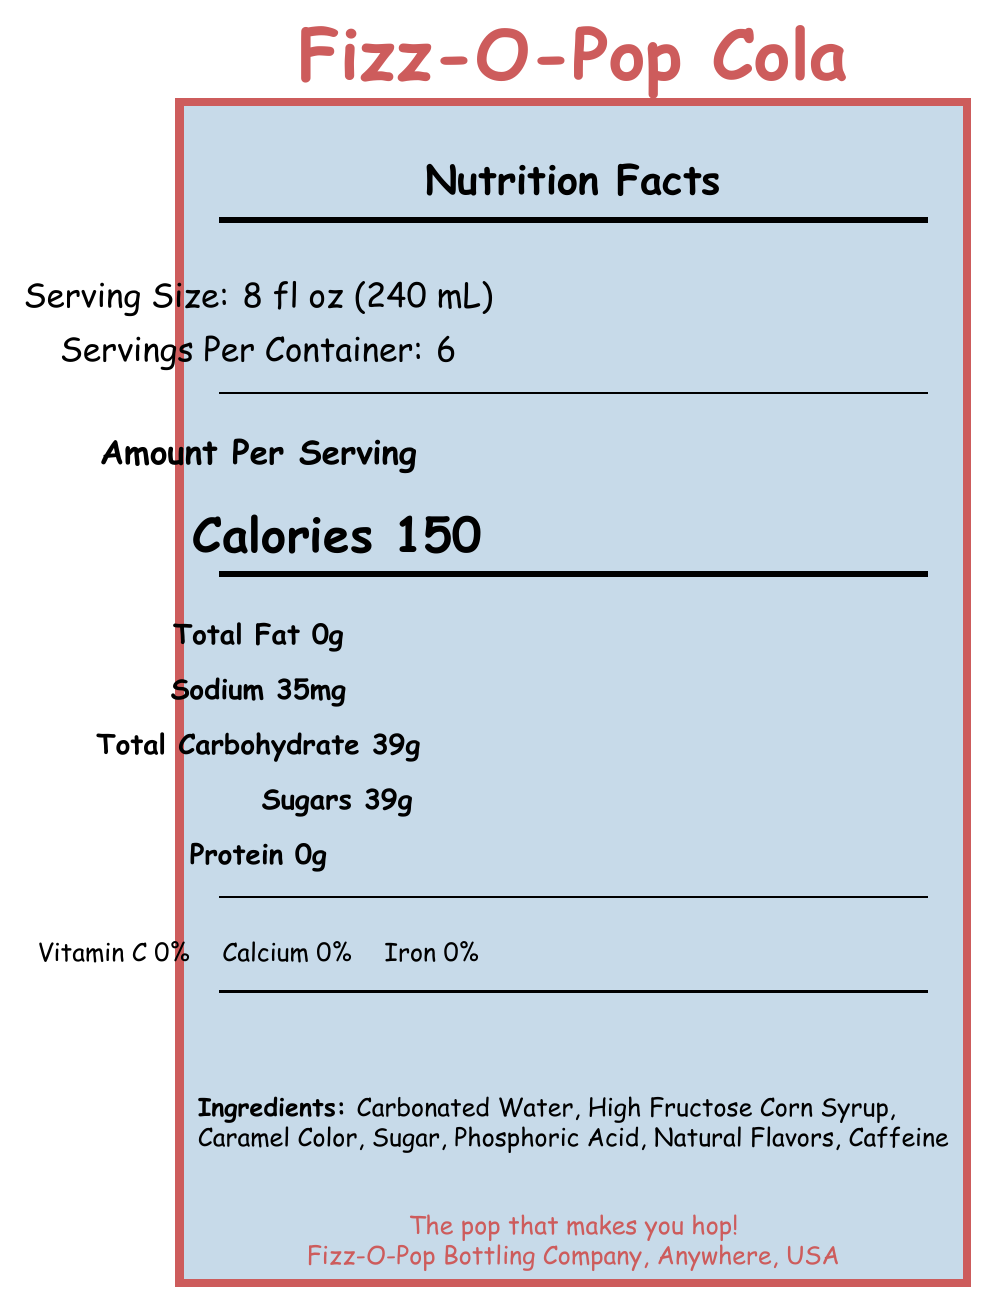what is the serving size of Fizz-O-Pop Cola? The document states "Serving Size: 8 fl oz (240 mL)".
Answer: 8 fl oz (240 mL) how many calories per serving? The document lists "Calories 150" under the "Amount Per Serving" section.
Answer: 150 which ingredient is listed first? The document lists "Ingredients: Carbonated Water, High Fructose Corn Syrup, Caramel Color, Sugar, Phosphoric Acid, Natural Flavors, Caffeine".
Answer: Carbonated Water what is the amount of sodium per serving? The document states "Sodium 35mg" under the nutritional information.
Answer: 35mg how much protein is in each serving? The document lists "Protein 0g" under the nutritional information.
Answer: 0g Fizz-O-Pop Cola has how many grams of sugar per serving? A. 20g B. 25g C. 39g D. 50g The document lists "Sugars 39g" under the nutritional information.
Answer: C. 39g What percentage of the daily value of sugar does one serving of Fizz-O-Pop provide? A. 50% B. 78% C. 100% The document includes additional information that states the sugar content is 78% of the daily value.
Answer: B. 78% Is there any fruit juice in Fizz-O-Pop Cola? The document states "Contains no fruit juice".
Answer: No Summarize the main idea of the document. The label breaks down the nutritional information, including calories, fats, sugars, and ingredients, presents fun historical facts, and additional consumer information like storage instructions and the manufacturer's slogan.
Answer: The document is a Nutrition Facts Label for Fizz-O-Pop Cola, a vintage soda from the 1950s, highlighting its high sugar content (39g per serving), zero nutritional benefits (no fat, protein, or vitamins), and fun facts about its history and consumption. how much caffeine is in Fizz-O-Pop Cola? The document lists caffeine as an ingredient but does not specify the amount.
Answer: Not enough information What is the slogan of the Fizz-O-Pop Bottling Company? The document states the slogan as "The pop that makes you hop!" at the bottom information section.
Answer: The pop that makes you hop! 